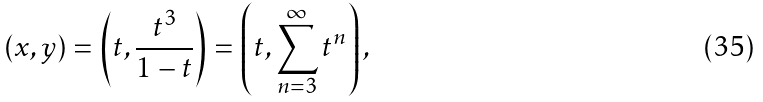Convert formula to latex. <formula><loc_0><loc_0><loc_500><loc_500>( x , y ) = \left ( t , { \frac { t ^ { 3 } } { 1 - t } } \right ) = \left ( t , \sum _ { n = 3 } ^ { \infty } t ^ { n } \right ) ,</formula> 